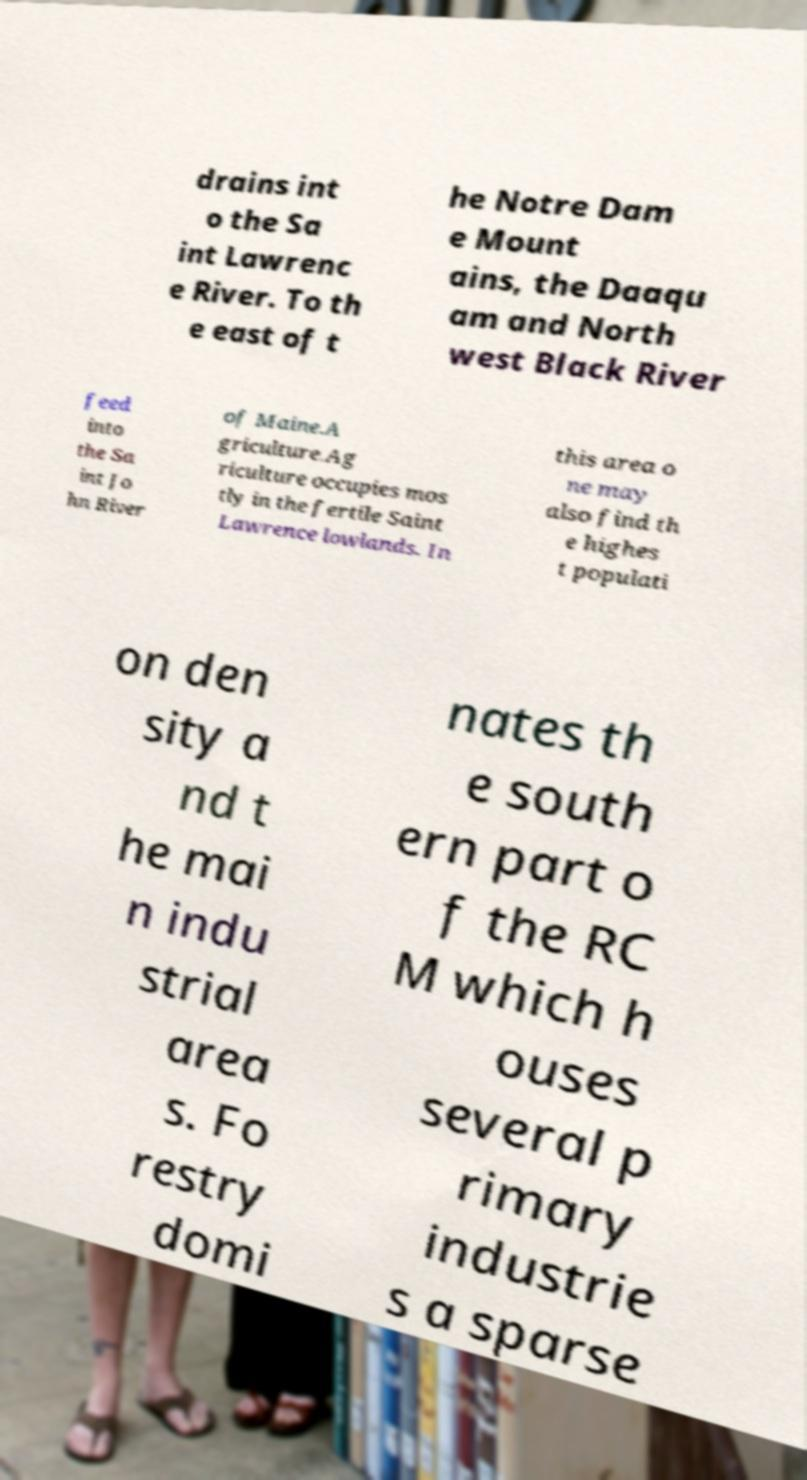Please read and relay the text visible in this image. What does it say? drains int o the Sa int Lawrenc e River. To th e east of t he Notre Dam e Mount ains, the Daaqu am and North west Black River feed into the Sa int Jo hn River of Maine.A griculture.Ag riculture occupies mos tly in the fertile Saint Lawrence lowlands. In this area o ne may also find th e highes t populati on den sity a nd t he mai n indu strial area s. Fo restry domi nates th e south ern part o f the RC M which h ouses several p rimary industrie s a sparse 